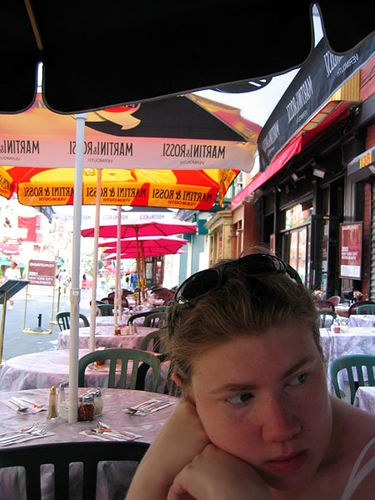Describe the objects in this image and their specific colors. I can see people in black, maroon, and brown tones, umbrella in black, gray, maroon, and orange tones, umbrella in black, lightpink, tan, and darkgray tones, umbrella in black, orange, red, and gold tones, and dining table in black, darkgray, lavender, gray, and pink tones in this image. 